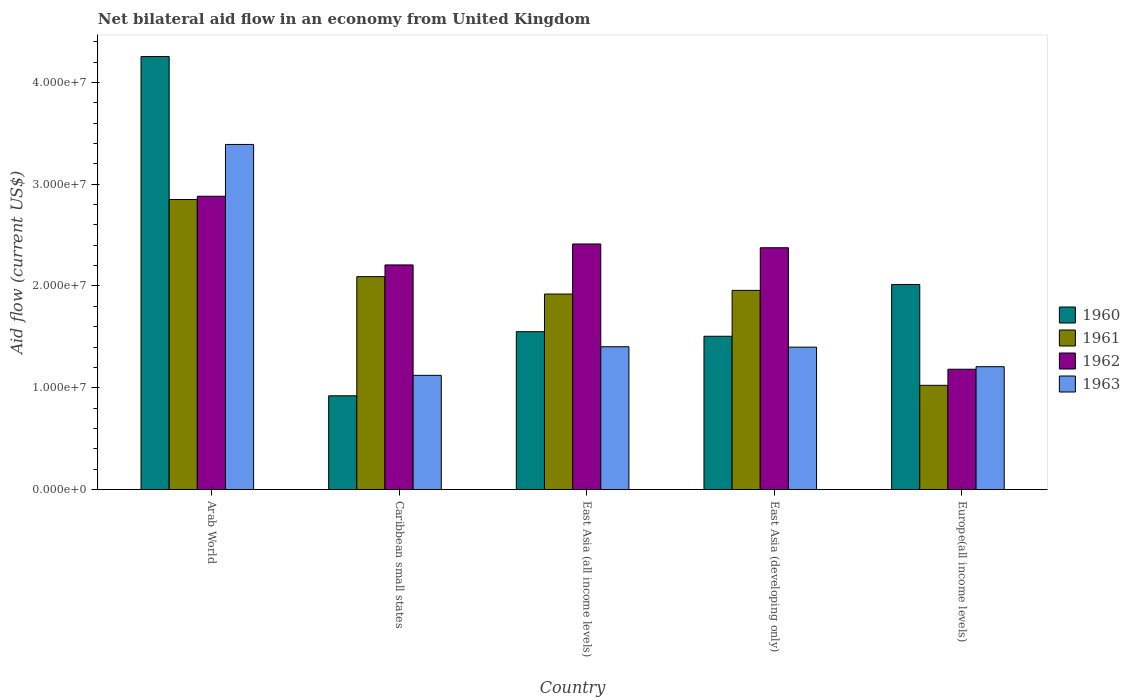How many different coloured bars are there?
Give a very brief answer. 4. How many groups of bars are there?
Give a very brief answer. 5. Are the number of bars per tick equal to the number of legend labels?
Offer a terse response. Yes. How many bars are there on the 4th tick from the left?
Provide a succinct answer. 4. How many bars are there on the 1st tick from the right?
Offer a terse response. 4. What is the label of the 5th group of bars from the left?
Offer a very short reply. Europe(all income levels). In how many cases, is the number of bars for a given country not equal to the number of legend labels?
Provide a succinct answer. 0. What is the net bilateral aid flow in 1963 in Europe(all income levels)?
Offer a very short reply. 1.21e+07. Across all countries, what is the maximum net bilateral aid flow in 1963?
Your response must be concise. 3.39e+07. Across all countries, what is the minimum net bilateral aid flow in 1961?
Offer a terse response. 1.02e+07. In which country was the net bilateral aid flow in 1962 maximum?
Your response must be concise. Arab World. In which country was the net bilateral aid flow in 1962 minimum?
Provide a succinct answer. Europe(all income levels). What is the total net bilateral aid flow in 1961 in the graph?
Ensure brevity in your answer.  9.84e+07. What is the difference between the net bilateral aid flow in 1961 in Caribbean small states and that in East Asia (developing only)?
Ensure brevity in your answer.  1.35e+06. What is the difference between the net bilateral aid flow in 1962 in Europe(all income levels) and the net bilateral aid flow in 1961 in Arab World?
Your response must be concise. -1.67e+07. What is the average net bilateral aid flow in 1961 per country?
Your answer should be very brief. 1.97e+07. What is the difference between the net bilateral aid flow of/in 1960 and net bilateral aid flow of/in 1962 in Europe(all income levels)?
Provide a short and direct response. 8.33e+06. In how many countries, is the net bilateral aid flow in 1963 greater than 18000000 US$?
Your answer should be very brief. 1. What is the ratio of the net bilateral aid flow in 1963 in Caribbean small states to that in East Asia (developing only)?
Give a very brief answer. 0.8. What is the difference between the highest and the second highest net bilateral aid flow in 1961?
Keep it short and to the point. 8.93e+06. What is the difference between the highest and the lowest net bilateral aid flow in 1961?
Provide a short and direct response. 1.83e+07. In how many countries, is the net bilateral aid flow in 1961 greater than the average net bilateral aid flow in 1961 taken over all countries?
Give a very brief answer. 2. What does the 2nd bar from the right in Arab World represents?
Your answer should be very brief. 1962. Is it the case that in every country, the sum of the net bilateral aid flow in 1962 and net bilateral aid flow in 1961 is greater than the net bilateral aid flow in 1963?
Provide a succinct answer. Yes. What is the difference between two consecutive major ticks on the Y-axis?
Offer a terse response. 1.00e+07. Does the graph contain any zero values?
Ensure brevity in your answer.  No. How many legend labels are there?
Make the answer very short. 4. How are the legend labels stacked?
Provide a short and direct response. Vertical. What is the title of the graph?
Offer a very short reply. Net bilateral aid flow in an economy from United Kingdom. Does "2001" appear as one of the legend labels in the graph?
Provide a succinct answer. No. What is the Aid flow (current US$) in 1960 in Arab World?
Keep it short and to the point. 4.26e+07. What is the Aid flow (current US$) of 1961 in Arab World?
Provide a succinct answer. 2.85e+07. What is the Aid flow (current US$) in 1962 in Arab World?
Provide a short and direct response. 2.88e+07. What is the Aid flow (current US$) of 1963 in Arab World?
Provide a short and direct response. 3.39e+07. What is the Aid flow (current US$) in 1960 in Caribbean small states?
Provide a short and direct response. 9.21e+06. What is the Aid flow (current US$) in 1961 in Caribbean small states?
Provide a short and direct response. 2.09e+07. What is the Aid flow (current US$) in 1962 in Caribbean small states?
Offer a very short reply. 2.21e+07. What is the Aid flow (current US$) of 1963 in Caribbean small states?
Your answer should be very brief. 1.12e+07. What is the Aid flow (current US$) of 1960 in East Asia (all income levels)?
Make the answer very short. 1.55e+07. What is the Aid flow (current US$) of 1961 in East Asia (all income levels)?
Offer a very short reply. 1.92e+07. What is the Aid flow (current US$) of 1962 in East Asia (all income levels)?
Your response must be concise. 2.41e+07. What is the Aid flow (current US$) of 1963 in East Asia (all income levels)?
Offer a very short reply. 1.40e+07. What is the Aid flow (current US$) of 1960 in East Asia (developing only)?
Give a very brief answer. 1.51e+07. What is the Aid flow (current US$) in 1961 in East Asia (developing only)?
Your answer should be very brief. 1.96e+07. What is the Aid flow (current US$) in 1962 in East Asia (developing only)?
Give a very brief answer. 2.38e+07. What is the Aid flow (current US$) in 1963 in East Asia (developing only)?
Make the answer very short. 1.40e+07. What is the Aid flow (current US$) in 1960 in Europe(all income levels)?
Make the answer very short. 2.02e+07. What is the Aid flow (current US$) in 1961 in Europe(all income levels)?
Provide a succinct answer. 1.02e+07. What is the Aid flow (current US$) in 1962 in Europe(all income levels)?
Your answer should be compact. 1.18e+07. What is the Aid flow (current US$) of 1963 in Europe(all income levels)?
Ensure brevity in your answer.  1.21e+07. Across all countries, what is the maximum Aid flow (current US$) of 1960?
Your answer should be compact. 4.26e+07. Across all countries, what is the maximum Aid flow (current US$) in 1961?
Offer a terse response. 2.85e+07. Across all countries, what is the maximum Aid flow (current US$) of 1962?
Your answer should be very brief. 2.88e+07. Across all countries, what is the maximum Aid flow (current US$) in 1963?
Give a very brief answer. 3.39e+07. Across all countries, what is the minimum Aid flow (current US$) of 1960?
Your answer should be very brief. 9.21e+06. Across all countries, what is the minimum Aid flow (current US$) in 1961?
Make the answer very short. 1.02e+07. Across all countries, what is the minimum Aid flow (current US$) of 1962?
Provide a short and direct response. 1.18e+07. Across all countries, what is the minimum Aid flow (current US$) of 1963?
Your answer should be very brief. 1.12e+07. What is the total Aid flow (current US$) in 1960 in the graph?
Provide a succinct answer. 1.02e+08. What is the total Aid flow (current US$) in 1961 in the graph?
Your answer should be compact. 9.84e+07. What is the total Aid flow (current US$) of 1962 in the graph?
Your answer should be compact. 1.11e+08. What is the total Aid flow (current US$) of 1963 in the graph?
Your answer should be very brief. 8.52e+07. What is the difference between the Aid flow (current US$) in 1960 in Arab World and that in Caribbean small states?
Provide a succinct answer. 3.33e+07. What is the difference between the Aid flow (current US$) of 1961 in Arab World and that in Caribbean small states?
Your answer should be compact. 7.58e+06. What is the difference between the Aid flow (current US$) of 1962 in Arab World and that in Caribbean small states?
Your answer should be compact. 6.75e+06. What is the difference between the Aid flow (current US$) in 1963 in Arab World and that in Caribbean small states?
Provide a short and direct response. 2.27e+07. What is the difference between the Aid flow (current US$) in 1960 in Arab World and that in East Asia (all income levels)?
Ensure brevity in your answer.  2.70e+07. What is the difference between the Aid flow (current US$) in 1961 in Arab World and that in East Asia (all income levels)?
Ensure brevity in your answer.  9.29e+06. What is the difference between the Aid flow (current US$) of 1962 in Arab World and that in East Asia (all income levels)?
Your response must be concise. 4.69e+06. What is the difference between the Aid flow (current US$) of 1963 in Arab World and that in East Asia (all income levels)?
Ensure brevity in your answer.  1.99e+07. What is the difference between the Aid flow (current US$) in 1960 in Arab World and that in East Asia (developing only)?
Offer a terse response. 2.75e+07. What is the difference between the Aid flow (current US$) of 1961 in Arab World and that in East Asia (developing only)?
Offer a terse response. 8.93e+06. What is the difference between the Aid flow (current US$) of 1962 in Arab World and that in East Asia (developing only)?
Give a very brief answer. 5.06e+06. What is the difference between the Aid flow (current US$) of 1963 in Arab World and that in East Asia (developing only)?
Give a very brief answer. 1.99e+07. What is the difference between the Aid flow (current US$) in 1960 in Arab World and that in Europe(all income levels)?
Ensure brevity in your answer.  2.24e+07. What is the difference between the Aid flow (current US$) of 1961 in Arab World and that in Europe(all income levels)?
Give a very brief answer. 1.83e+07. What is the difference between the Aid flow (current US$) in 1962 in Arab World and that in Europe(all income levels)?
Ensure brevity in your answer.  1.70e+07. What is the difference between the Aid flow (current US$) in 1963 in Arab World and that in Europe(all income levels)?
Provide a short and direct response. 2.18e+07. What is the difference between the Aid flow (current US$) in 1960 in Caribbean small states and that in East Asia (all income levels)?
Your answer should be compact. -6.30e+06. What is the difference between the Aid flow (current US$) in 1961 in Caribbean small states and that in East Asia (all income levels)?
Give a very brief answer. 1.71e+06. What is the difference between the Aid flow (current US$) of 1962 in Caribbean small states and that in East Asia (all income levels)?
Your response must be concise. -2.06e+06. What is the difference between the Aid flow (current US$) of 1963 in Caribbean small states and that in East Asia (all income levels)?
Ensure brevity in your answer.  -2.81e+06. What is the difference between the Aid flow (current US$) in 1960 in Caribbean small states and that in East Asia (developing only)?
Provide a succinct answer. -5.85e+06. What is the difference between the Aid flow (current US$) in 1961 in Caribbean small states and that in East Asia (developing only)?
Provide a succinct answer. 1.35e+06. What is the difference between the Aid flow (current US$) in 1962 in Caribbean small states and that in East Asia (developing only)?
Ensure brevity in your answer.  -1.69e+06. What is the difference between the Aid flow (current US$) in 1963 in Caribbean small states and that in East Asia (developing only)?
Ensure brevity in your answer.  -2.77e+06. What is the difference between the Aid flow (current US$) in 1960 in Caribbean small states and that in Europe(all income levels)?
Make the answer very short. -1.09e+07. What is the difference between the Aid flow (current US$) in 1961 in Caribbean small states and that in Europe(all income levels)?
Provide a short and direct response. 1.07e+07. What is the difference between the Aid flow (current US$) of 1962 in Caribbean small states and that in Europe(all income levels)?
Your answer should be compact. 1.02e+07. What is the difference between the Aid flow (current US$) in 1963 in Caribbean small states and that in Europe(all income levels)?
Offer a very short reply. -8.50e+05. What is the difference between the Aid flow (current US$) in 1960 in East Asia (all income levels) and that in East Asia (developing only)?
Your answer should be very brief. 4.50e+05. What is the difference between the Aid flow (current US$) in 1961 in East Asia (all income levels) and that in East Asia (developing only)?
Offer a very short reply. -3.60e+05. What is the difference between the Aid flow (current US$) of 1962 in East Asia (all income levels) and that in East Asia (developing only)?
Keep it short and to the point. 3.70e+05. What is the difference between the Aid flow (current US$) in 1963 in East Asia (all income levels) and that in East Asia (developing only)?
Your answer should be compact. 4.00e+04. What is the difference between the Aid flow (current US$) in 1960 in East Asia (all income levels) and that in Europe(all income levels)?
Ensure brevity in your answer.  -4.64e+06. What is the difference between the Aid flow (current US$) in 1961 in East Asia (all income levels) and that in Europe(all income levels)?
Provide a short and direct response. 8.97e+06. What is the difference between the Aid flow (current US$) in 1962 in East Asia (all income levels) and that in Europe(all income levels)?
Keep it short and to the point. 1.23e+07. What is the difference between the Aid flow (current US$) of 1963 in East Asia (all income levels) and that in Europe(all income levels)?
Make the answer very short. 1.96e+06. What is the difference between the Aid flow (current US$) in 1960 in East Asia (developing only) and that in Europe(all income levels)?
Provide a succinct answer. -5.09e+06. What is the difference between the Aid flow (current US$) of 1961 in East Asia (developing only) and that in Europe(all income levels)?
Ensure brevity in your answer.  9.33e+06. What is the difference between the Aid flow (current US$) of 1962 in East Asia (developing only) and that in Europe(all income levels)?
Make the answer very short. 1.19e+07. What is the difference between the Aid flow (current US$) in 1963 in East Asia (developing only) and that in Europe(all income levels)?
Keep it short and to the point. 1.92e+06. What is the difference between the Aid flow (current US$) in 1960 in Arab World and the Aid flow (current US$) in 1961 in Caribbean small states?
Offer a very short reply. 2.16e+07. What is the difference between the Aid flow (current US$) of 1960 in Arab World and the Aid flow (current US$) of 1962 in Caribbean small states?
Ensure brevity in your answer.  2.05e+07. What is the difference between the Aid flow (current US$) in 1960 in Arab World and the Aid flow (current US$) in 1963 in Caribbean small states?
Keep it short and to the point. 3.13e+07. What is the difference between the Aid flow (current US$) in 1961 in Arab World and the Aid flow (current US$) in 1962 in Caribbean small states?
Offer a very short reply. 6.43e+06. What is the difference between the Aid flow (current US$) of 1961 in Arab World and the Aid flow (current US$) of 1963 in Caribbean small states?
Make the answer very short. 1.73e+07. What is the difference between the Aid flow (current US$) in 1962 in Arab World and the Aid flow (current US$) in 1963 in Caribbean small states?
Offer a very short reply. 1.76e+07. What is the difference between the Aid flow (current US$) in 1960 in Arab World and the Aid flow (current US$) in 1961 in East Asia (all income levels)?
Offer a very short reply. 2.33e+07. What is the difference between the Aid flow (current US$) in 1960 in Arab World and the Aid flow (current US$) in 1962 in East Asia (all income levels)?
Your answer should be very brief. 1.84e+07. What is the difference between the Aid flow (current US$) in 1960 in Arab World and the Aid flow (current US$) in 1963 in East Asia (all income levels)?
Provide a succinct answer. 2.85e+07. What is the difference between the Aid flow (current US$) in 1961 in Arab World and the Aid flow (current US$) in 1962 in East Asia (all income levels)?
Give a very brief answer. 4.37e+06. What is the difference between the Aid flow (current US$) in 1961 in Arab World and the Aid flow (current US$) in 1963 in East Asia (all income levels)?
Offer a terse response. 1.45e+07. What is the difference between the Aid flow (current US$) in 1962 in Arab World and the Aid flow (current US$) in 1963 in East Asia (all income levels)?
Make the answer very short. 1.48e+07. What is the difference between the Aid flow (current US$) of 1960 in Arab World and the Aid flow (current US$) of 1961 in East Asia (developing only)?
Provide a short and direct response. 2.30e+07. What is the difference between the Aid flow (current US$) of 1960 in Arab World and the Aid flow (current US$) of 1962 in East Asia (developing only)?
Provide a succinct answer. 1.88e+07. What is the difference between the Aid flow (current US$) of 1960 in Arab World and the Aid flow (current US$) of 1963 in East Asia (developing only)?
Provide a short and direct response. 2.86e+07. What is the difference between the Aid flow (current US$) in 1961 in Arab World and the Aid flow (current US$) in 1962 in East Asia (developing only)?
Your response must be concise. 4.74e+06. What is the difference between the Aid flow (current US$) of 1961 in Arab World and the Aid flow (current US$) of 1963 in East Asia (developing only)?
Keep it short and to the point. 1.45e+07. What is the difference between the Aid flow (current US$) in 1962 in Arab World and the Aid flow (current US$) in 1963 in East Asia (developing only)?
Ensure brevity in your answer.  1.48e+07. What is the difference between the Aid flow (current US$) of 1960 in Arab World and the Aid flow (current US$) of 1961 in Europe(all income levels)?
Provide a short and direct response. 3.23e+07. What is the difference between the Aid flow (current US$) of 1960 in Arab World and the Aid flow (current US$) of 1962 in Europe(all income levels)?
Give a very brief answer. 3.07e+07. What is the difference between the Aid flow (current US$) in 1960 in Arab World and the Aid flow (current US$) in 1963 in Europe(all income levels)?
Give a very brief answer. 3.05e+07. What is the difference between the Aid flow (current US$) in 1961 in Arab World and the Aid flow (current US$) in 1962 in Europe(all income levels)?
Provide a short and direct response. 1.67e+07. What is the difference between the Aid flow (current US$) in 1961 in Arab World and the Aid flow (current US$) in 1963 in Europe(all income levels)?
Give a very brief answer. 1.64e+07. What is the difference between the Aid flow (current US$) of 1962 in Arab World and the Aid flow (current US$) of 1963 in Europe(all income levels)?
Offer a terse response. 1.68e+07. What is the difference between the Aid flow (current US$) of 1960 in Caribbean small states and the Aid flow (current US$) of 1961 in East Asia (all income levels)?
Keep it short and to the point. -1.00e+07. What is the difference between the Aid flow (current US$) in 1960 in Caribbean small states and the Aid flow (current US$) in 1962 in East Asia (all income levels)?
Offer a terse response. -1.49e+07. What is the difference between the Aid flow (current US$) of 1960 in Caribbean small states and the Aid flow (current US$) of 1963 in East Asia (all income levels)?
Your response must be concise. -4.82e+06. What is the difference between the Aid flow (current US$) in 1961 in Caribbean small states and the Aid flow (current US$) in 1962 in East Asia (all income levels)?
Provide a succinct answer. -3.21e+06. What is the difference between the Aid flow (current US$) in 1961 in Caribbean small states and the Aid flow (current US$) in 1963 in East Asia (all income levels)?
Give a very brief answer. 6.89e+06. What is the difference between the Aid flow (current US$) of 1962 in Caribbean small states and the Aid flow (current US$) of 1963 in East Asia (all income levels)?
Your answer should be very brief. 8.04e+06. What is the difference between the Aid flow (current US$) of 1960 in Caribbean small states and the Aid flow (current US$) of 1961 in East Asia (developing only)?
Keep it short and to the point. -1.04e+07. What is the difference between the Aid flow (current US$) of 1960 in Caribbean small states and the Aid flow (current US$) of 1962 in East Asia (developing only)?
Provide a succinct answer. -1.46e+07. What is the difference between the Aid flow (current US$) of 1960 in Caribbean small states and the Aid flow (current US$) of 1963 in East Asia (developing only)?
Ensure brevity in your answer.  -4.78e+06. What is the difference between the Aid flow (current US$) of 1961 in Caribbean small states and the Aid flow (current US$) of 1962 in East Asia (developing only)?
Keep it short and to the point. -2.84e+06. What is the difference between the Aid flow (current US$) of 1961 in Caribbean small states and the Aid flow (current US$) of 1963 in East Asia (developing only)?
Your answer should be very brief. 6.93e+06. What is the difference between the Aid flow (current US$) of 1962 in Caribbean small states and the Aid flow (current US$) of 1963 in East Asia (developing only)?
Offer a very short reply. 8.08e+06. What is the difference between the Aid flow (current US$) of 1960 in Caribbean small states and the Aid flow (current US$) of 1961 in Europe(all income levels)?
Give a very brief answer. -1.03e+06. What is the difference between the Aid flow (current US$) of 1960 in Caribbean small states and the Aid flow (current US$) of 1962 in Europe(all income levels)?
Offer a terse response. -2.61e+06. What is the difference between the Aid flow (current US$) of 1960 in Caribbean small states and the Aid flow (current US$) of 1963 in Europe(all income levels)?
Give a very brief answer. -2.86e+06. What is the difference between the Aid flow (current US$) of 1961 in Caribbean small states and the Aid flow (current US$) of 1962 in Europe(all income levels)?
Keep it short and to the point. 9.10e+06. What is the difference between the Aid flow (current US$) of 1961 in Caribbean small states and the Aid flow (current US$) of 1963 in Europe(all income levels)?
Make the answer very short. 8.85e+06. What is the difference between the Aid flow (current US$) in 1960 in East Asia (all income levels) and the Aid flow (current US$) in 1961 in East Asia (developing only)?
Your answer should be compact. -4.06e+06. What is the difference between the Aid flow (current US$) in 1960 in East Asia (all income levels) and the Aid flow (current US$) in 1962 in East Asia (developing only)?
Your response must be concise. -8.25e+06. What is the difference between the Aid flow (current US$) of 1960 in East Asia (all income levels) and the Aid flow (current US$) of 1963 in East Asia (developing only)?
Offer a very short reply. 1.52e+06. What is the difference between the Aid flow (current US$) of 1961 in East Asia (all income levels) and the Aid flow (current US$) of 1962 in East Asia (developing only)?
Your response must be concise. -4.55e+06. What is the difference between the Aid flow (current US$) in 1961 in East Asia (all income levels) and the Aid flow (current US$) in 1963 in East Asia (developing only)?
Offer a very short reply. 5.22e+06. What is the difference between the Aid flow (current US$) in 1962 in East Asia (all income levels) and the Aid flow (current US$) in 1963 in East Asia (developing only)?
Your answer should be very brief. 1.01e+07. What is the difference between the Aid flow (current US$) in 1960 in East Asia (all income levels) and the Aid flow (current US$) in 1961 in Europe(all income levels)?
Provide a succinct answer. 5.27e+06. What is the difference between the Aid flow (current US$) in 1960 in East Asia (all income levels) and the Aid flow (current US$) in 1962 in Europe(all income levels)?
Your answer should be very brief. 3.69e+06. What is the difference between the Aid flow (current US$) in 1960 in East Asia (all income levels) and the Aid flow (current US$) in 1963 in Europe(all income levels)?
Your answer should be compact. 3.44e+06. What is the difference between the Aid flow (current US$) in 1961 in East Asia (all income levels) and the Aid flow (current US$) in 1962 in Europe(all income levels)?
Your response must be concise. 7.39e+06. What is the difference between the Aid flow (current US$) of 1961 in East Asia (all income levels) and the Aid flow (current US$) of 1963 in Europe(all income levels)?
Offer a very short reply. 7.14e+06. What is the difference between the Aid flow (current US$) of 1962 in East Asia (all income levels) and the Aid flow (current US$) of 1963 in Europe(all income levels)?
Make the answer very short. 1.21e+07. What is the difference between the Aid flow (current US$) in 1960 in East Asia (developing only) and the Aid flow (current US$) in 1961 in Europe(all income levels)?
Your answer should be very brief. 4.82e+06. What is the difference between the Aid flow (current US$) of 1960 in East Asia (developing only) and the Aid flow (current US$) of 1962 in Europe(all income levels)?
Your answer should be very brief. 3.24e+06. What is the difference between the Aid flow (current US$) of 1960 in East Asia (developing only) and the Aid flow (current US$) of 1963 in Europe(all income levels)?
Offer a terse response. 2.99e+06. What is the difference between the Aid flow (current US$) in 1961 in East Asia (developing only) and the Aid flow (current US$) in 1962 in Europe(all income levels)?
Your answer should be compact. 7.75e+06. What is the difference between the Aid flow (current US$) of 1961 in East Asia (developing only) and the Aid flow (current US$) of 1963 in Europe(all income levels)?
Your response must be concise. 7.50e+06. What is the difference between the Aid flow (current US$) of 1962 in East Asia (developing only) and the Aid flow (current US$) of 1963 in Europe(all income levels)?
Provide a succinct answer. 1.17e+07. What is the average Aid flow (current US$) in 1960 per country?
Give a very brief answer. 2.05e+07. What is the average Aid flow (current US$) in 1961 per country?
Your answer should be compact. 1.97e+07. What is the average Aid flow (current US$) of 1962 per country?
Give a very brief answer. 2.21e+07. What is the average Aid flow (current US$) of 1963 per country?
Offer a terse response. 1.70e+07. What is the difference between the Aid flow (current US$) in 1960 and Aid flow (current US$) in 1961 in Arab World?
Your response must be concise. 1.40e+07. What is the difference between the Aid flow (current US$) of 1960 and Aid flow (current US$) of 1962 in Arab World?
Your answer should be compact. 1.37e+07. What is the difference between the Aid flow (current US$) of 1960 and Aid flow (current US$) of 1963 in Arab World?
Your answer should be compact. 8.64e+06. What is the difference between the Aid flow (current US$) in 1961 and Aid flow (current US$) in 1962 in Arab World?
Your response must be concise. -3.20e+05. What is the difference between the Aid flow (current US$) of 1961 and Aid flow (current US$) of 1963 in Arab World?
Ensure brevity in your answer.  -5.41e+06. What is the difference between the Aid flow (current US$) in 1962 and Aid flow (current US$) in 1963 in Arab World?
Your answer should be compact. -5.09e+06. What is the difference between the Aid flow (current US$) of 1960 and Aid flow (current US$) of 1961 in Caribbean small states?
Provide a short and direct response. -1.17e+07. What is the difference between the Aid flow (current US$) of 1960 and Aid flow (current US$) of 1962 in Caribbean small states?
Offer a terse response. -1.29e+07. What is the difference between the Aid flow (current US$) in 1960 and Aid flow (current US$) in 1963 in Caribbean small states?
Your answer should be compact. -2.01e+06. What is the difference between the Aid flow (current US$) of 1961 and Aid flow (current US$) of 1962 in Caribbean small states?
Your answer should be compact. -1.15e+06. What is the difference between the Aid flow (current US$) of 1961 and Aid flow (current US$) of 1963 in Caribbean small states?
Offer a very short reply. 9.70e+06. What is the difference between the Aid flow (current US$) in 1962 and Aid flow (current US$) in 1963 in Caribbean small states?
Offer a terse response. 1.08e+07. What is the difference between the Aid flow (current US$) of 1960 and Aid flow (current US$) of 1961 in East Asia (all income levels)?
Provide a short and direct response. -3.70e+06. What is the difference between the Aid flow (current US$) of 1960 and Aid flow (current US$) of 1962 in East Asia (all income levels)?
Your answer should be very brief. -8.62e+06. What is the difference between the Aid flow (current US$) of 1960 and Aid flow (current US$) of 1963 in East Asia (all income levels)?
Offer a very short reply. 1.48e+06. What is the difference between the Aid flow (current US$) in 1961 and Aid flow (current US$) in 1962 in East Asia (all income levels)?
Make the answer very short. -4.92e+06. What is the difference between the Aid flow (current US$) of 1961 and Aid flow (current US$) of 1963 in East Asia (all income levels)?
Your response must be concise. 5.18e+06. What is the difference between the Aid flow (current US$) in 1962 and Aid flow (current US$) in 1963 in East Asia (all income levels)?
Offer a very short reply. 1.01e+07. What is the difference between the Aid flow (current US$) of 1960 and Aid flow (current US$) of 1961 in East Asia (developing only)?
Give a very brief answer. -4.51e+06. What is the difference between the Aid flow (current US$) of 1960 and Aid flow (current US$) of 1962 in East Asia (developing only)?
Your answer should be very brief. -8.70e+06. What is the difference between the Aid flow (current US$) in 1960 and Aid flow (current US$) in 1963 in East Asia (developing only)?
Provide a succinct answer. 1.07e+06. What is the difference between the Aid flow (current US$) in 1961 and Aid flow (current US$) in 1962 in East Asia (developing only)?
Your response must be concise. -4.19e+06. What is the difference between the Aid flow (current US$) in 1961 and Aid flow (current US$) in 1963 in East Asia (developing only)?
Ensure brevity in your answer.  5.58e+06. What is the difference between the Aid flow (current US$) of 1962 and Aid flow (current US$) of 1963 in East Asia (developing only)?
Your answer should be compact. 9.77e+06. What is the difference between the Aid flow (current US$) in 1960 and Aid flow (current US$) in 1961 in Europe(all income levels)?
Make the answer very short. 9.91e+06. What is the difference between the Aid flow (current US$) of 1960 and Aid flow (current US$) of 1962 in Europe(all income levels)?
Provide a succinct answer. 8.33e+06. What is the difference between the Aid flow (current US$) of 1960 and Aid flow (current US$) of 1963 in Europe(all income levels)?
Your answer should be compact. 8.08e+06. What is the difference between the Aid flow (current US$) in 1961 and Aid flow (current US$) in 1962 in Europe(all income levels)?
Offer a very short reply. -1.58e+06. What is the difference between the Aid flow (current US$) in 1961 and Aid flow (current US$) in 1963 in Europe(all income levels)?
Keep it short and to the point. -1.83e+06. What is the difference between the Aid flow (current US$) of 1962 and Aid flow (current US$) of 1963 in Europe(all income levels)?
Your answer should be compact. -2.50e+05. What is the ratio of the Aid flow (current US$) of 1960 in Arab World to that in Caribbean small states?
Offer a terse response. 4.62. What is the ratio of the Aid flow (current US$) in 1961 in Arab World to that in Caribbean small states?
Your answer should be compact. 1.36. What is the ratio of the Aid flow (current US$) in 1962 in Arab World to that in Caribbean small states?
Provide a succinct answer. 1.31. What is the ratio of the Aid flow (current US$) in 1963 in Arab World to that in Caribbean small states?
Provide a short and direct response. 3.02. What is the ratio of the Aid flow (current US$) in 1960 in Arab World to that in East Asia (all income levels)?
Your answer should be very brief. 2.74. What is the ratio of the Aid flow (current US$) of 1961 in Arab World to that in East Asia (all income levels)?
Ensure brevity in your answer.  1.48. What is the ratio of the Aid flow (current US$) in 1962 in Arab World to that in East Asia (all income levels)?
Make the answer very short. 1.19. What is the ratio of the Aid flow (current US$) in 1963 in Arab World to that in East Asia (all income levels)?
Your answer should be compact. 2.42. What is the ratio of the Aid flow (current US$) of 1960 in Arab World to that in East Asia (developing only)?
Give a very brief answer. 2.83. What is the ratio of the Aid flow (current US$) of 1961 in Arab World to that in East Asia (developing only)?
Offer a terse response. 1.46. What is the ratio of the Aid flow (current US$) of 1962 in Arab World to that in East Asia (developing only)?
Provide a short and direct response. 1.21. What is the ratio of the Aid flow (current US$) in 1963 in Arab World to that in East Asia (developing only)?
Give a very brief answer. 2.42. What is the ratio of the Aid flow (current US$) of 1960 in Arab World to that in Europe(all income levels)?
Provide a short and direct response. 2.11. What is the ratio of the Aid flow (current US$) in 1961 in Arab World to that in Europe(all income levels)?
Offer a terse response. 2.78. What is the ratio of the Aid flow (current US$) of 1962 in Arab World to that in Europe(all income levels)?
Make the answer very short. 2.44. What is the ratio of the Aid flow (current US$) of 1963 in Arab World to that in Europe(all income levels)?
Give a very brief answer. 2.81. What is the ratio of the Aid flow (current US$) in 1960 in Caribbean small states to that in East Asia (all income levels)?
Your answer should be compact. 0.59. What is the ratio of the Aid flow (current US$) of 1961 in Caribbean small states to that in East Asia (all income levels)?
Your answer should be compact. 1.09. What is the ratio of the Aid flow (current US$) of 1962 in Caribbean small states to that in East Asia (all income levels)?
Provide a succinct answer. 0.91. What is the ratio of the Aid flow (current US$) in 1963 in Caribbean small states to that in East Asia (all income levels)?
Ensure brevity in your answer.  0.8. What is the ratio of the Aid flow (current US$) in 1960 in Caribbean small states to that in East Asia (developing only)?
Provide a short and direct response. 0.61. What is the ratio of the Aid flow (current US$) in 1961 in Caribbean small states to that in East Asia (developing only)?
Your answer should be very brief. 1.07. What is the ratio of the Aid flow (current US$) of 1962 in Caribbean small states to that in East Asia (developing only)?
Offer a terse response. 0.93. What is the ratio of the Aid flow (current US$) of 1963 in Caribbean small states to that in East Asia (developing only)?
Ensure brevity in your answer.  0.8. What is the ratio of the Aid flow (current US$) in 1960 in Caribbean small states to that in Europe(all income levels)?
Give a very brief answer. 0.46. What is the ratio of the Aid flow (current US$) in 1961 in Caribbean small states to that in Europe(all income levels)?
Your answer should be compact. 2.04. What is the ratio of the Aid flow (current US$) in 1962 in Caribbean small states to that in Europe(all income levels)?
Make the answer very short. 1.87. What is the ratio of the Aid flow (current US$) in 1963 in Caribbean small states to that in Europe(all income levels)?
Your answer should be very brief. 0.93. What is the ratio of the Aid flow (current US$) of 1960 in East Asia (all income levels) to that in East Asia (developing only)?
Your answer should be compact. 1.03. What is the ratio of the Aid flow (current US$) of 1961 in East Asia (all income levels) to that in East Asia (developing only)?
Your answer should be very brief. 0.98. What is the ratio of the Aid flow (current US$) of 1962 in East Asia (all income levels) to that in East Asia (developing only)?
Offer a terse response. 1.02. What is the ratio of the Aid flow (current US$) of 1963 in East Asia (all income levels) to that in East Asia (developing only)?
Keep it short and to the point. 1. What is the ratio of the Aid flow (current US$) of 1960 in East Asia (all income levels) to that in Europe(all income levels)?
Ensure brevity in your answer.  0.77. What is the ratio of the Aid flow (current US$) in 1961 in East Asia (all income levels) to that in Europe(all income levels)?
Your answer should be very brief. 1.88. What is the ratio of the Aid flow (current US$) in 1962 in East Asia (all income levels) to that in Europe(all income levels)?
Your answer should be compact. 2.04. What is the ratio of the Aid flow (current US$) of 1963 in East Asia (all income levels) to that in Europe(all income levels)?
Provide a succinct answer. 1.16. What is the ratio of the Aid flow (current US$) of 1960 in East Asia (developing only) to that in Europe(all income levels)?
Keep it short and to the point. 0.75. What is the ratio of the Aid flow (current US$) in 1961 in East Asia (developing only) to that in Europe(all income levels)?
Your response must be concise. 1.91. What is the ratio of the Aid flow (current US$) of 1962 in East Asia (developing only) to that in Europe(all income levels)?
Make the answer very short. 2.01. What is the ratio of the Aid flow (current US$) of 1963 in East Asia (developing only) to that in Europe(all income levels)?
Your answer should be compact. 1.16. What is the difference between the highest and the second highest Aid flow (current US$) of 1960?
Give a very brief answer. 2.24e+07. What is the difference between the highest and the second highest Aid flow (current US$) of 1961?
Offer a very short reply. 7.58e+06. What is the difference between the highest and the second highest Aid flow (current US$) of 1962?
Your answer should be very brief. 4.69e+06. What is the difference between the highest and the second highest Aid flow (current US$) of 1963?
Offer a very short reply. 1.99e+07. What is the difference between the highest and the lowest Aid flow (current US$) in 1960?
Provide a succinct answer. 3.33e+07. What is the difference between the highest and the lowest Aid flow (current US$) of 1961?
Your response must be concise. 1.83e+07. What is the difference between the highest and the lowest Aid flow (current US$) in 1962?
Make the answer very short. 1.70e+07. What is the difference between the highest and the lowest Aid flow (current US$) in 1963?
Give a very brief answer. 2.27e+07. 